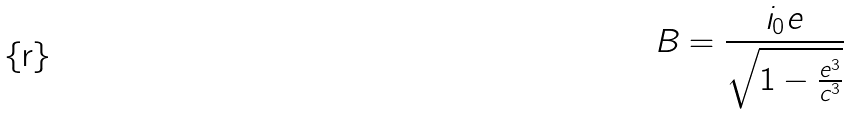<formula> <loc_0><loc_0><loc_500><loc_500>B = \frac { i _ { 0 } e } { \sqrt { 1 - \frac { e ^ { 3 } } { c ^ { 3 } } } }</formula> 